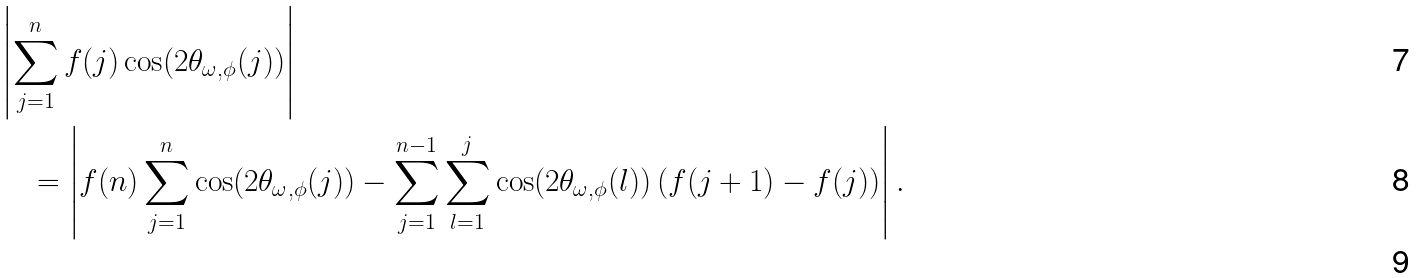<formula> <loc_0><loc_0><loc_500><loc_500>& \left | \sum _ { j = 1 } ^ { n } f ( j ) \cos ( 2 \theta _ { \omega , \phi } ( j ) ) \right | \\ & \quad = \left | f ( n ) \sum _ { j = 1 } ^ { n } \cos ( 2 \theta _ { \omega , \phi } ( j ) ) - \sum _ { j = 1 } ^ { n - 1 } \sum _ { l = 1 } ^ { j } \cos ( 2 \theta _ { \omega , \phi } ( l ) ) \left ( f ( j + 1 ) - f ( j ) \right ) \right | . \\</formula> 